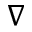<formula> <loc_0><loc_0><loc_500><loc_500>\nabla</formula> 